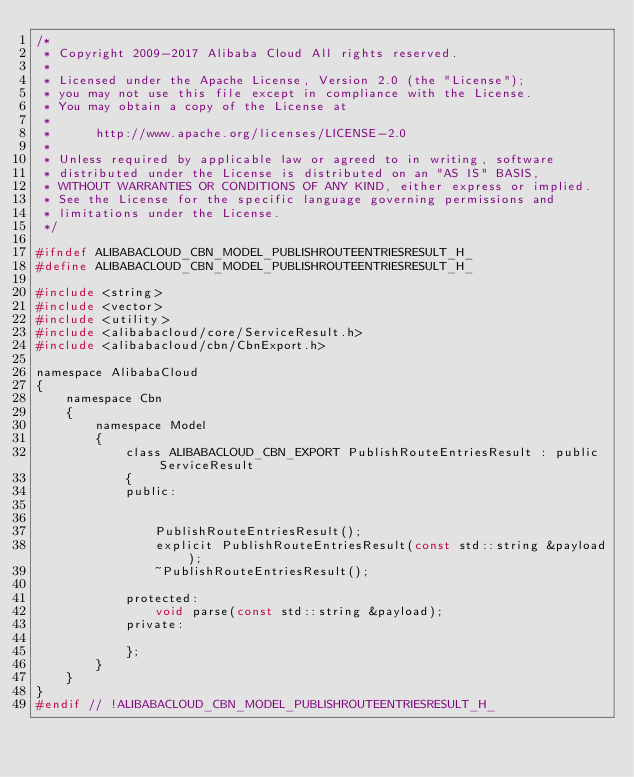<code> <loc_0><loc_0><loc_500><loc_500><_C_>/*
 * Copyright 2009-2017 Alibaba Cloud All rights reserved.
 * 
 * Licensed under the Apache License, Version 2.0 (the "License");
 * you may not use this file except in compliance with the License.
 * You may obtain a copy of the License at
 * 
 *      http://www.apache.org/licenses/LICENSE-2.0
 * 
 * Unless required by applicable law or agreed to in writing, software
 * distributed under the License is distributed on an "AS IS" BASIS,
 * WITHOUT WARRANTIES OR CONDITIONS OF ANY KIND, either express or implied.
 * See the License for the specific language governing permissions and
 * limitations under the License.
 */

#ifndef ALIBABACLOUD_CBN_MODEL_PUBLISHROUTEENTRIESRESULT_H_
#define ALIBABACLOUD_CBN_MODEL_PUBLISHROUTEENTRIESRESULT_H_

#include <string>
#include <vector>
#include <utility>
#include <alibabacloud/core/ServiceResult.h>
#include <alibabacloud/cbn/CbnExport.h>

namespace AlibabaCloud
{
	namespace Cbn
	{
		namespace Model
		{
			class ALIBABACLOUD_CBN_EXPORT PublishRouteEntriesResult : public ServiceResult
			{
			public:


				PublishRouteEntriesResult();
				explicit PublishRouteEntriesResult(const std::string &payload);
				~PublishRouteEntriesResult();

			protected:
				void parse(const std::string &payload);
			private:

			};
		}
	}
}
#endif // !ALIBABACLOUD_CBN_MODEL_PUBLISHROUTEENTRIESRESULT_H_</code> 